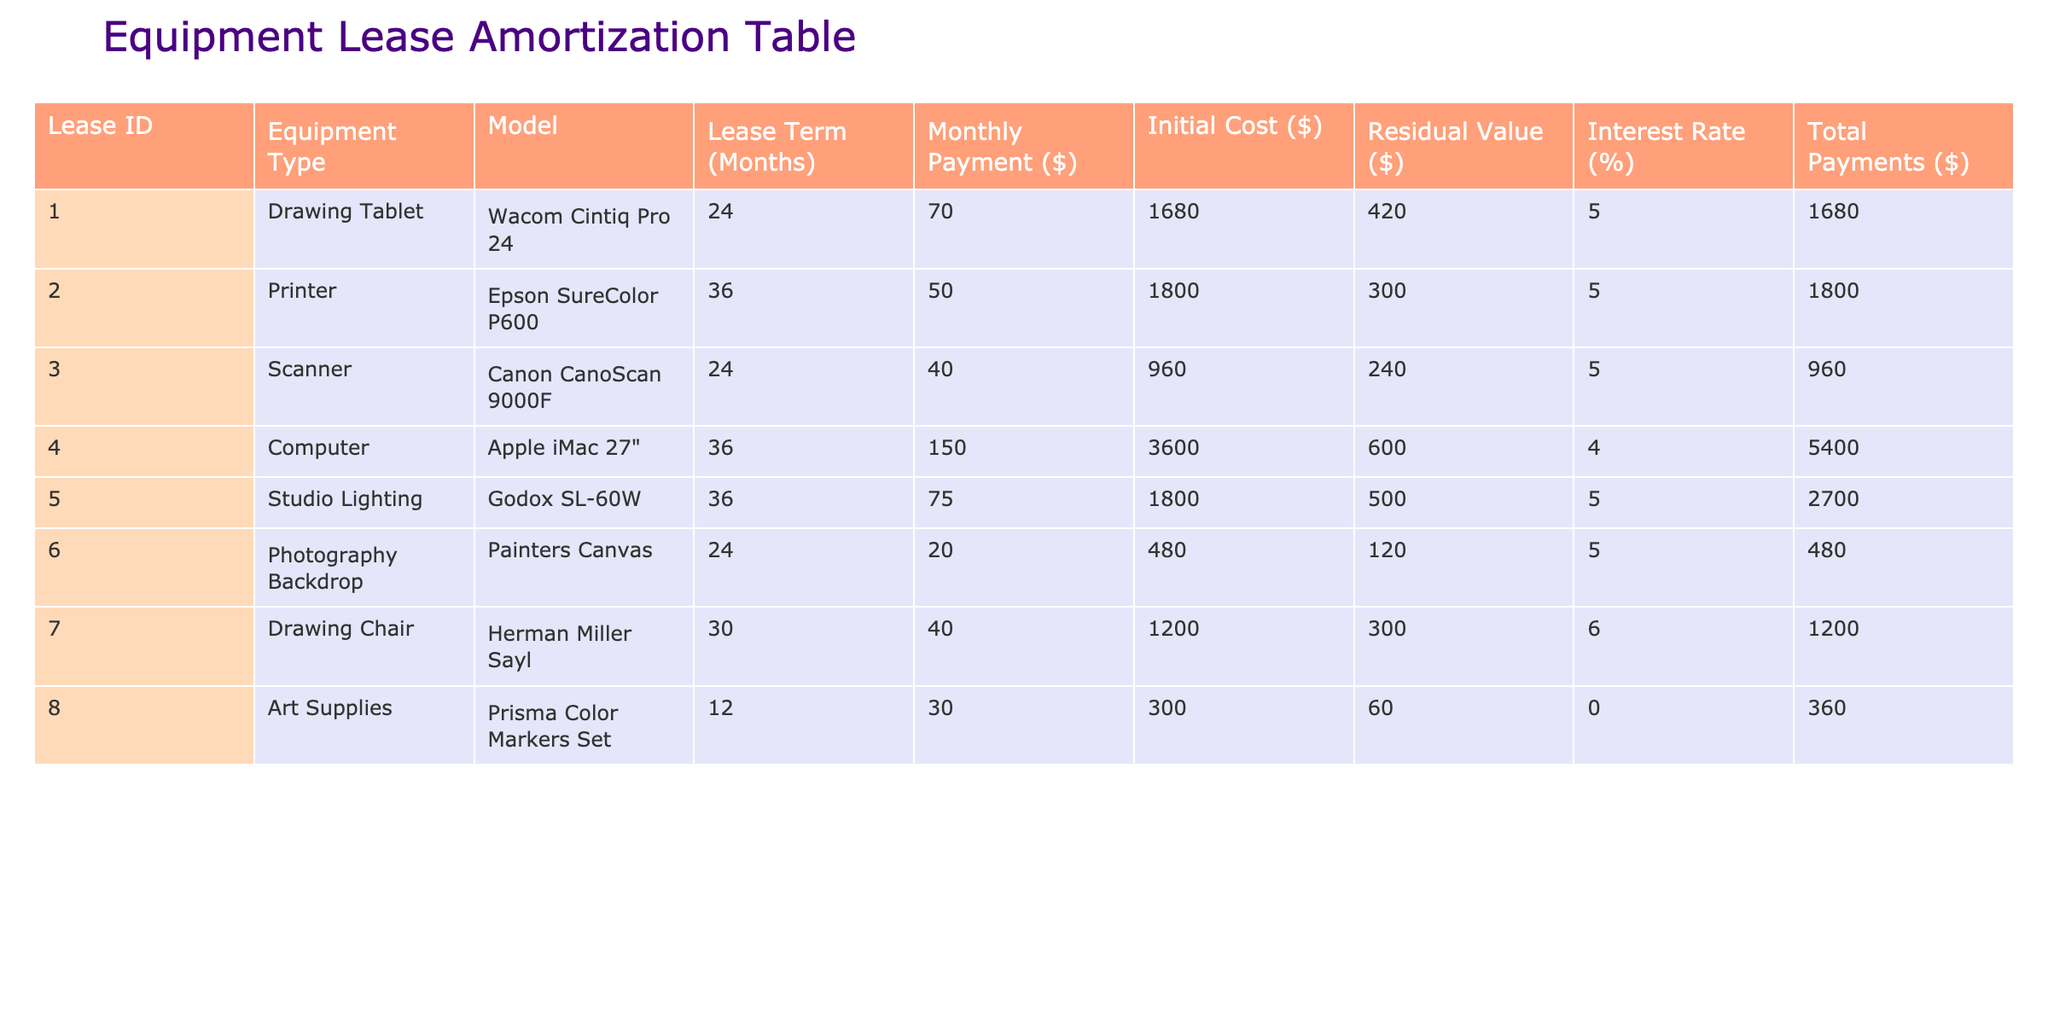What is the monthly payment for the Wacom Cintiq Pro 24? The monthly payment for the Wacom Cintiq Pro 24 can be found in the "Monthly Payment ($)" column corresponding to the lease ID for this equipment. That entry shows 70.
Answer: 70 What is the total payment for the Epson SureColor P600? The total payment for the Epson SureColor P600 is listed in the "Total Payments ($)" column next to this equipment type. The total payment is 1800.
Answer: 1800 How many months is the lease term for the Apple iMac 27"? The lease term for the Apple iMac 27" is extracted from the "Lease Term (Months)" column for this specific model. It shows 36 months.
Answer: 36 What is the average monthly payment for all leases? To find the average monthly payment, we can add up all the monthly payments (70 + 50 + 40 + 150 + 75 + 20 + 40 + 30 = 475) and divide by the number of leases (8), which equals 59.375.
Answer: 59.375 Is the residual value of the Canon CanoScan 9000F greater than that of the Godox SL-60W? By comparing the residual values found in the "Residual Value ($)" column, the Canon CanoScan 9000F has a residual value of 240, while the Godox SL-60W has a value of 500. Since 240 is not greater than 500, the answer is no.
Answer: No Which equipment type has the highest initial cost? We look at the "Initial Cost ($)" column and find that the Apple iMac 27" has the highest initial cost at 3600, compared to others.
Answer: Apple iMac 27" What is the total initial cost of all equipment? To find the total initial cost, we sum all the values in the "Initial Cost ($)" column (1680 + 1800 + 960 + 3600 + 1800 + 480 + 1200 + 300 = 12020). Thus the total initial cost is 12020.
Answer: 12020 How many leases have an interest rate of 5%? We need to count how many entries in the "Interest Rate (%)" column are equal to 5%. Upon checking, there are 5 entries that meet this criterion: Drawing Tablet, Printer, Scanner, Studio Lighting, and Photography Backdrop.
Answer: 5 What is the difference in total payments between the Drawing Tablet and the Computer? The total payment for the Drawing Tablet is 1680, and for the Computer, it's 5400. The difference is calculated as 5400 - 1680 = 3720.
Answer: 3720 